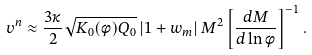Convert formula to latex. <formula><loc_0><loc_0><loc_500><loc_500>v ^ { n } \approx \frac { 3 \kappa } { 2 } \sqrt { K _ { 0 } ( \phi ) Q _ { 0 } } \left | 1 + w _ { m } \right | M ^ { 2 } \left [ \frac { d M } { d \ln \phi } \right ] ^ { - 1 } .</formula> 